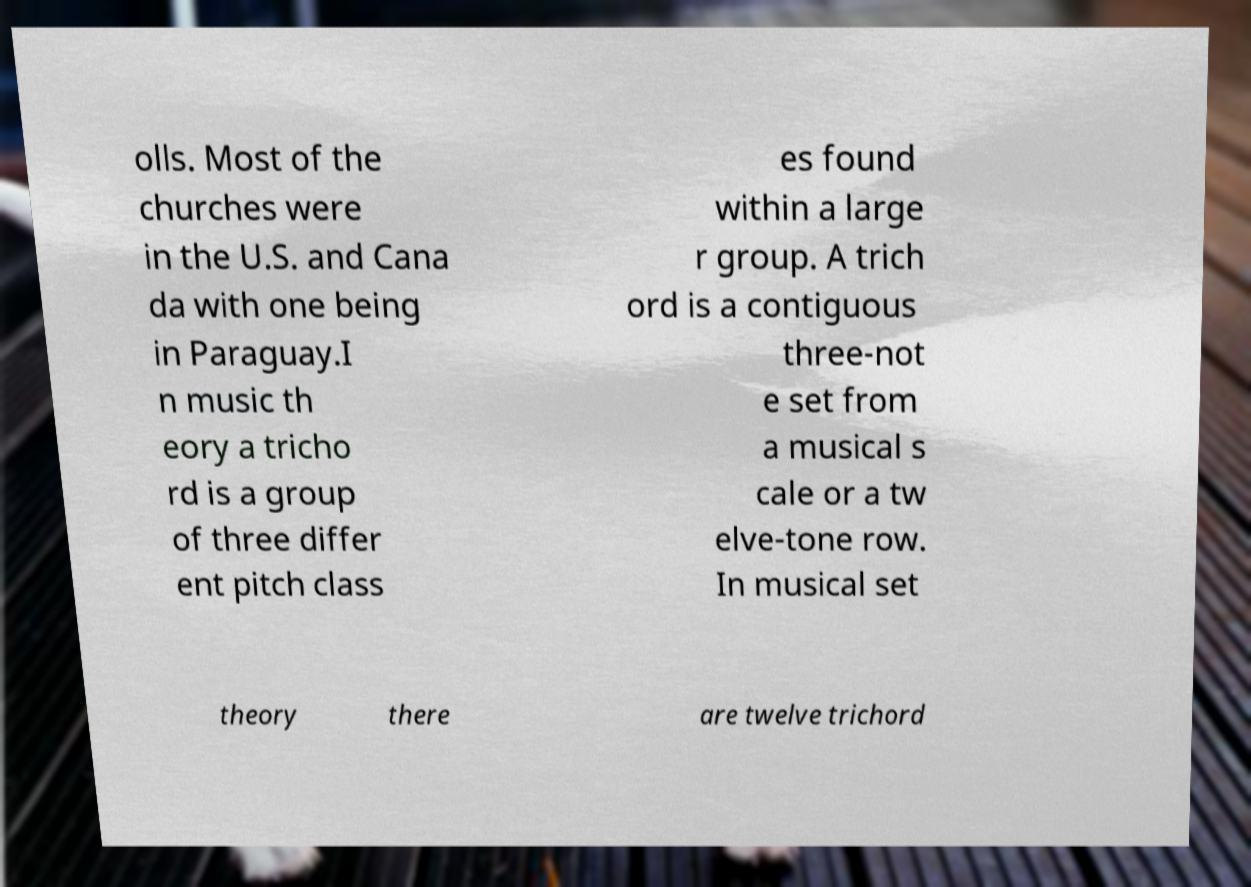Could you assist in decoding the text presented in this image and type it out clearly? olls. Most of the churches were in the U.S. and Cana da with one being in Paraguay.I n music th eory a tricho rd is a group of three differ ent pitch class es found within a large r group. A trich ord is a contiguous three-not e set from a musical s cale or a tw elve-tone row. In musical set theory there are twelve trichord 